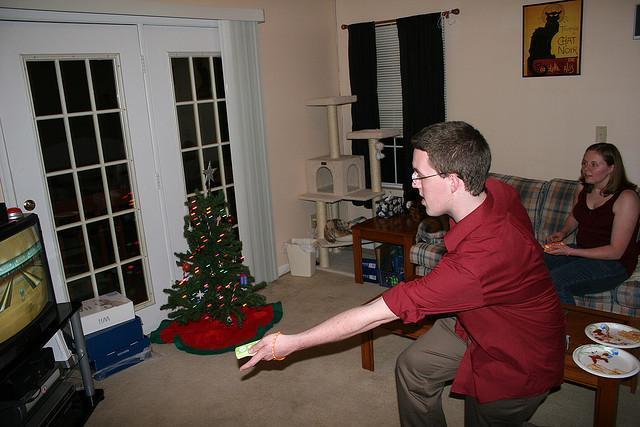How many people are in the photograph behind the man?
Give a very brief answer. 1. How many people are there?
Give a very brief answer. 2. How many toothbrushes are pictured?
Give a very brief answer. 0. 